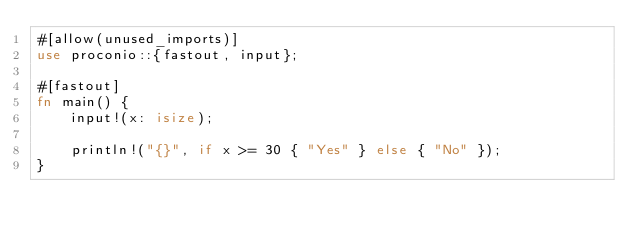Convert code to text. <code><loc_0><loc_0><loc_500><loc_500><_Rust_>#[allow(unused_imports)]
use proconio::{fastout, input};

#[fastout]
fn main() {
    input!(x: isize);

    println!("{}", if x >= 30 { "Yes" } else { "No" });
}
</code> 